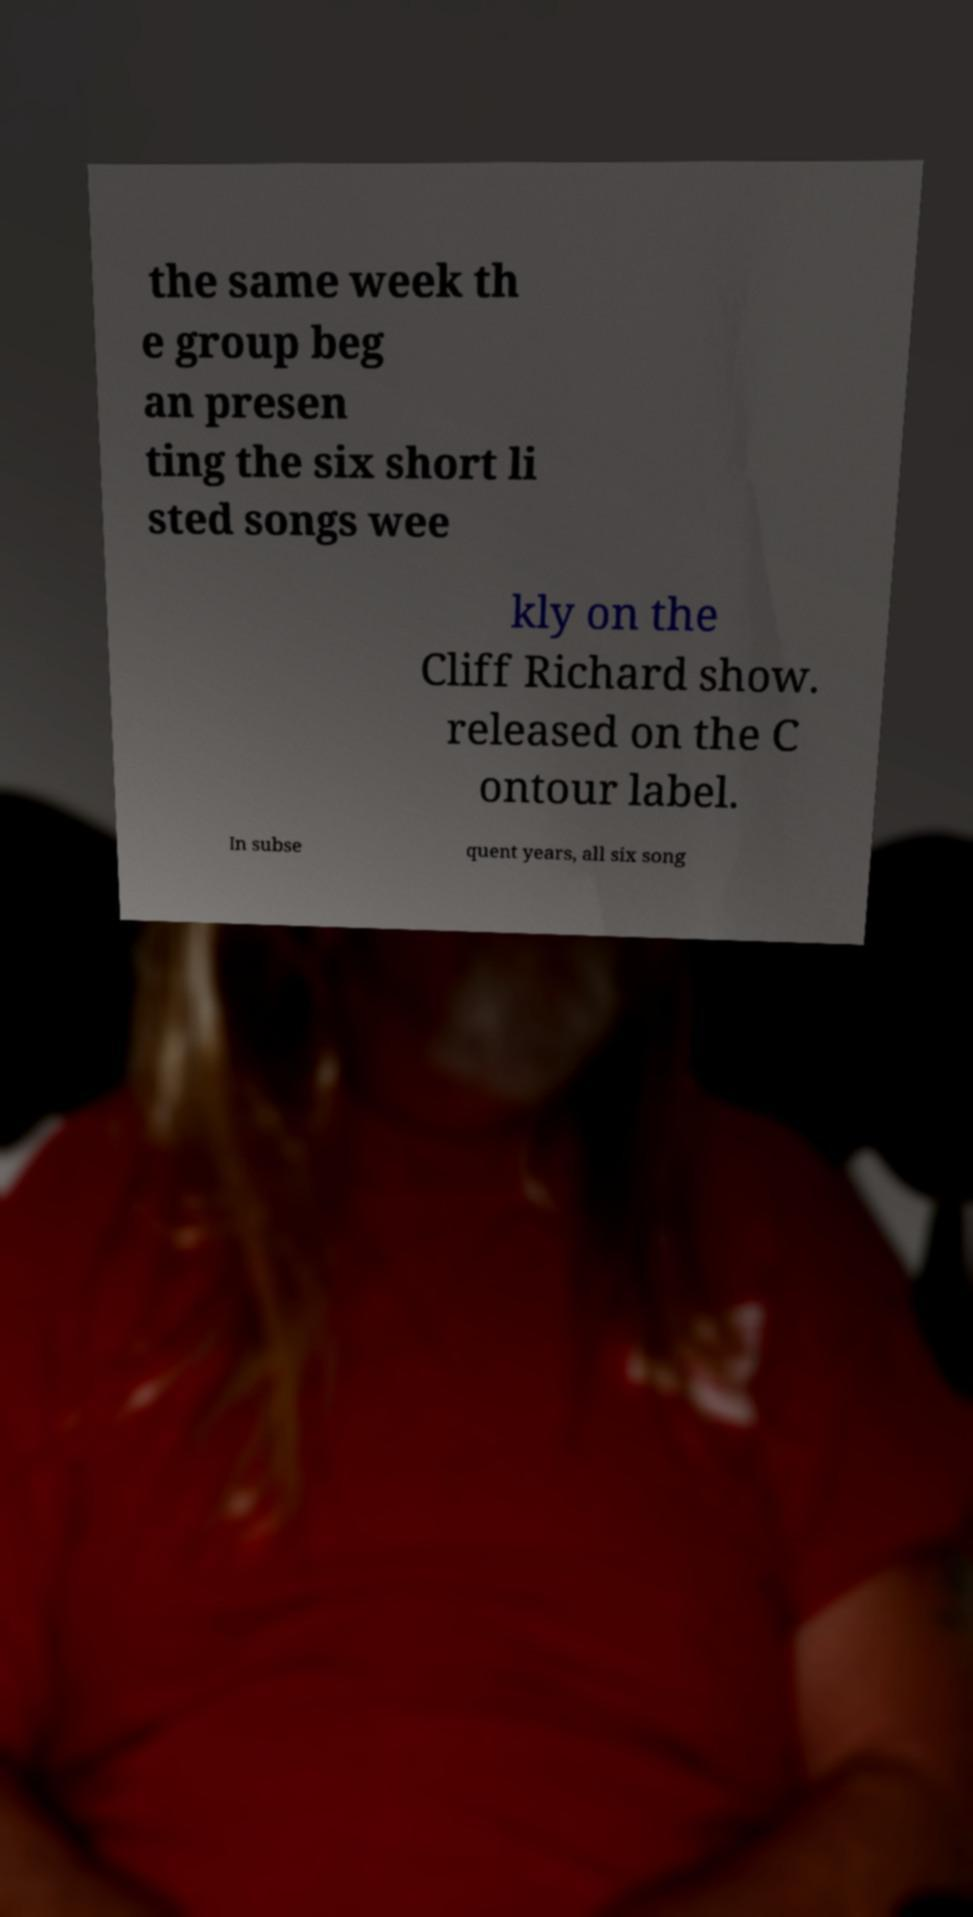Please read and relay the text visible in this image. What does it say? the same week th e group beg an presen ting the six short li sted songs wee kly on the Cliff Richard show. released on the C ontour label. In subse quent years, all six song 